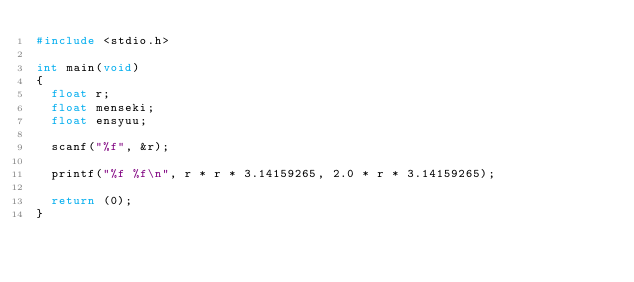Convert code to text. <code><loc_0><loc_0><loc_500><loc_500><_C_>#include <stdio.h>

int main(void)
{
	float r;
	float menseki;
	float ensyuu;
	
	scanf("%f", &r);
	
	printf("%f %f\n", r * r * 3.14159265, 2.0 * r * 3.14159265);
	
	return (0);
}</code> 